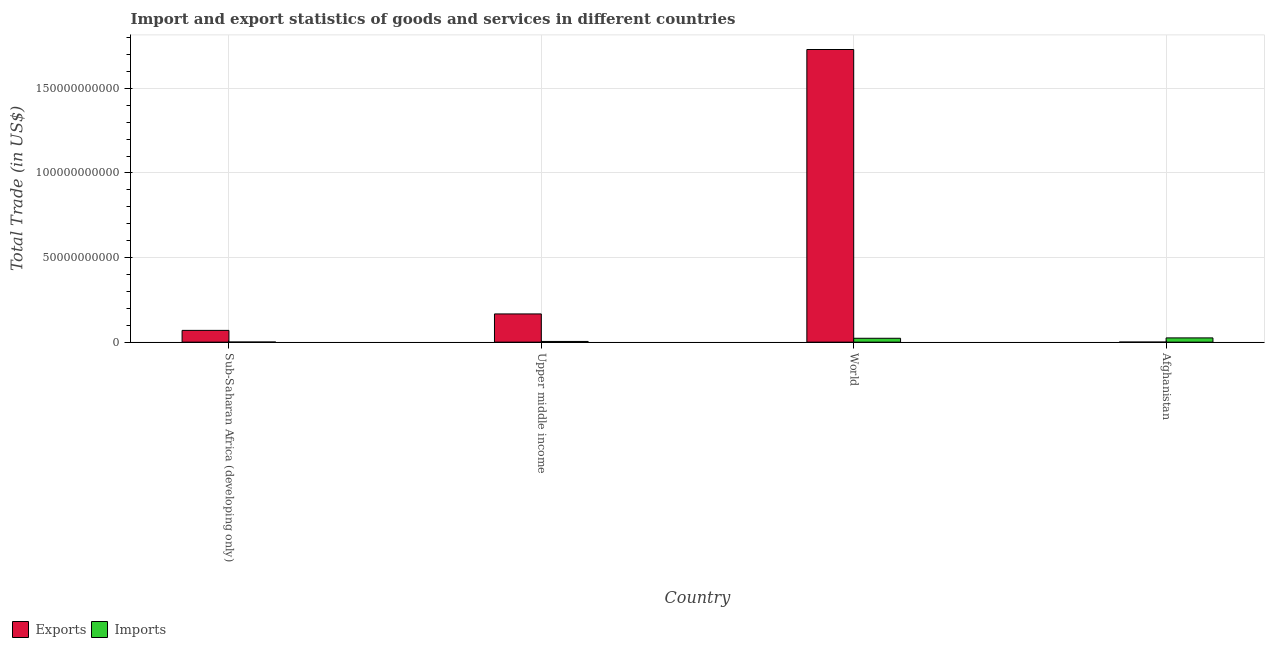How many different coloured bars are there?
Provide a short and direct response. 2. Are the number of bars on each tick of the X-axis equal?
Your answer should be compact. Yes. How many bars are there on the 1st tick from the right?
Offer a very short reply. 2. What is the label of the 2nd group of bars from the left?
Your response must be concise. Upper middle income. In how many cases, is the number of bars for a given country not equal to the number of legend labels?
Provide a succinct answer. 0. What is the imports of goods and services in Afghanistan?
Offer a very short reply. 2.51e+09. Across all countries, what is the maximum imports of goods and services?
Provide a short and direct response. 2.51e+09. Across all countries, what is the minimum imports of goods and services?
Provide a succinct answer. 5.11e+07. In which country was the imports of goods and services maximum?
Offer a terse response. Afghanistan. In which country was the imports of goods and services minimum?
Keep it short and to the point. Sub-Saharan Africa (developing only). What is the total imports of goods and services in the graph?
Offer a terse response. 5.27e+09. What is the difference between the export of goods and services in Afghanistan and that in Sub-Saharan Africa (developing only)?
Provide a short and direct response. -6.93e+09. What is the difference between the export of goods and services in Sub-Saharan Africa (developing only) and the imports of goods and services in World?
Keep it short and to the point. 4.66e+09. What is the average imports of goods and services per country?
Give a very brief answer. 1.32e+09. What is the difference between the imports of goods and services and export of goods and services in Upper middle income?
Your response must be concise. -1.63e+1. In how many countries, is the imports of goods and services greater than 120000000000 US$?
Your answer should be very brief. 0. What is the ratio of the export of goods and services in Sub-Saharan Africa (developing only) to that in World?
Offer a very short reply. 0.04. What is the difference between the highest and the second highest export of goods and services?
Your response must be concise. 1.56e+11. What is the difference between the highest and the lowest imports of goods and services?
Give a very brief answer. 2.46e+09. In how many countries, is the imports of goods and services greater than the average imports of goods and services taken over all countries?
Your answer should be compact. 2. Is the sum of the imports of goods and services in Afghanistan and Sub-Saharan Africa (developing only) greater than the maximum export of goods and services across all countries?
Offer a terse response. No. What does the 2nd bar from the left in World represents?
Keep it short and to the point. Imports. What does the 1st bar from the right in Upper middle income represents?
Provide a short and direct response. Imports. Are all the bars in the graph horizontal?
Make the answer very short. No. Are the values on the major ticks of Y-axis written in scientific E-notation?
Your answer should be very brief. No. Does the graph contain any zero values?
Your answer should be very brief. No. Where does the legend appear in the graph?
Your response must be concise. Bottom left. How are the legend labels stacked?
Keep it short and to the point. Horizontal. What is the title of the graph?
Give a very brief answer. Import and export statistics of goods and services in different countries. What is the label or title of the Y-axis?
Offer a terse response. Total Trade (in US$). What is the Total Trade (in US$) of Exports in Sub-Saharan Africa (developing only)?
Give a very brief answer. 6.95e+09. What is the Total Trade (in US$) in Imports in Sub-Saharan Africa (developing only)?
Offer a very short reply. 5.11e+07. What is the Total Trade (in US$) in Exports in Upper middle income?
Your response must be concise. 1.67e+1. What is the Total Trade (in US$) of Imports in Upper middle income?
Your answer should be very brief. 4.17e+08. What is the Total Trade (in US$) in Exports in World?
Offer a very short reply. 1.73e+11. What is the Total Trade (in US$) in Imports in World?
Your answer should be compact. 2.29e+09. What is the Total Trade (in US$) in Exports in Afghanistan?
Your answer should be very brief. 2.67e+07. What is the Total Trade (in US$) of Imports in Afghanistan?
Offer a very short reply. 2.51e+09. Across all countries, what is the maximum Total Trade (in US$) of Exports?
Provide a short and direct response. 1.73e+11. Across all countries, what is the maximum Total Trade (in US$) in Imports?
Offer a terse response. 2.51e+09. Across all countries, what is the minimum Total Trade (in US$) of Exports?
Offer a very short reply. 2.67e+07. Across all countries, what is the minimum Total Trade (in US$) in Imports?
Keep it short and to the point. 5.11e+07. What is the total Total Trade (in US$) of Exports in the graph?
Provide a short and direct response. 1.97e+11. What is the total Total Trade (in US$) in Imports in the graph?
Your answer should be compact. 5.27e+09. What is the difference between the Total Trade (in US$) of Exports in Sub-Saharan Africa (developing only) and that in Upper middle income?
Offer a terse response. -9.72e+09. What is the difference between the Total Trade (in US$) of Imports in Sub-Saharan Africa (developing only) and that in Upper middle income?
Offer a terse response. -3.66e+08. What is the difference between the Total Trade (in US$) of Exports in Sub-Saharan Africa (developing only) and that in World?
Your response must be concise. -1.66e+11. What is the difference between the Total Trade (in US$) in Imports in Sub-Saharan Africa (developing only) and that in World?
Your answer should be very brief. -2.24e+09. What is the difference between the Total Trade (in US$) in Exports in Sub-Saharan Africa (developing only) and that in Afghanistan?
Give a very brief answer. 6.93e+09. What is the difference between the Total Trade (in US$) in Imports in Sub-Saharan Africa (developing only) and that in Afghanistan?
Keep it short and to the point. -2.46e+09. What is the difference between the Total Trade (in US$) of Exports in Upper middle income and that in World?
Give a very brief answer. -1.56e+11. What is the difference between the Total Trade (in US$) of Imports in Upper middle income and that in World?
Make the answer very short. -1.88e+09. What is the difference between the Total Trade (in US$) in Exports in Upper middle income and that in Afghanistan?
Make the answer very short. 1.66e+1. What is the difference between the Total Trade (in US$) of Imports in Upper middle income and that in Afghanistan?
Give a very brief answer. -2.10e+09. What is the difference between the Total Trade (in US$) of Exports in World and that in Afghanistan?
Keep it short and to the point. 1.73e+11. What is the difference between the Total Trade (in US$) of Imports in World and that in Afghanistan?
Your answer should be very brief. -2.18e+08. What is the difference between the Total Trade (in US$) of Exports in Sub-Saharan Africa (developing only) and the Total Trade (in US$) of Imports in Upper middle income?
Ensure brevity in your answer.  6.54e+09. What is the difference between the Total Trade (in US$) in Exports in Sub-Saharan Africa (developing only) and the Total Trade (in US$) in Imports in World?
Keep it short and to the point. 4.66e+09. What is the difference between the Total Trade (in US$) in Exports in Sub-Saharan Africa (developing only) and the Total Trade (in US$) in Imports in Afghanistan?
Ensure brevity in your answer.  4.44e+09. What is the difference between the Total Trade (in US$) in Exports in Upper middle income and the Total Trade (in US$) in Imports in World?
Provide a short and direct response. 1.44e+1. What is the difference between the Total Trade (in US$) of Exports in Upper middle income and the Total Trade (in US$) of Imports in Afghanistan?
Offer a terse response. 1.42e+1. What is the difference between the Total Trade (in US$) in Exports in World and the Total Trade (in US$) in Imports in Afghanistan?
Your response must be concise. 1.70e+11. What is the average Total Trade (in US$) in Exports per country?
Provide a succinct answer. 4.92e+1. What is the average Total Trade (in US$) in Imports per country?
Make the answer very short. 1.32e+09. What is the difference between the Total Trade (in US$) of Exports and Total Trade (in US$) of Imports in Sub-Saharan Africa (developing only)?
Offer a terse response. 6.90e+09. What is the difference between the Total Trade (in US$) in Exports and Total Trade (in US$) in Imports in Upper middle income?
Provide a succinct answer. 1.63e+1. What is the difference between the Total Trade (in US$) of Exports and Total Trade (in US$) of Imports in World?
Provide a succinct answer. 1.71e+11. What is the difference between the Total Trade (in US$) of Exports and Total Trade (in US$) of Imports in Afghanistan?
Provide a succinct answer. -2.49e+09. What is the ratio of the Total Trade (in US$) of Exports in Sub-Saharan Africa (developing only) to that in Upper middle income?
Offer a terse response. 0.42. What is the ratio of the Total Trade (in US$) in Imports in Sub-Saharan Africa (developing only) to that in Upper middle income?
Your answer should be very brief. 0.12. What is the ratio of the Total Trade (in US$) of Exports in Sub-Saharan Africa (developing only) to that in World?
Offer a terse response. 0.04. What is the ratio of the Total Trade (in US$) in Imports in Sub-Saharan Africa (developing only) to that in World?
Offer a very short reply. 0.02. What is the ratio of the Total Trade (in US$) in Exports in Sub-Saharan Africa (developing only) to that in Afghanistan?
Provide a short and direct response. 260.78. What is the ratio of the Total Trade (in US$) of Imports in Sub-Saharan Africa (developing only) to that in Afghanistan?
Provide a succinct answer. 0.02. What is the ratio of the Total Trade (in US$) of Exports in Upper middle income to that in World?
Offer a terse response. 0.1. What is the ratio of the Total Trade (in US$) of Imports in Upper middle income to that in World?
Your answer should be compact. 0.18. What is the ratio of the Total Trade (in US$) of Exports in Upper middle income to that in Afghanistan?
Your answer should be compact. 625.33. What is the ratio of the Total Trade (in US$) in Imports in Upper middle income to that in Afghanistan?
Give a very brief answer. 0.17. What is the ratio of the Total Trade (in US$) of Exports in World to that in Afghanistan?
Offer a very short reply. 6486.07. What is the ratio of the Total Trade (in US$) in Imports in World to that in Afghanistan?
Give a very brief answer. 0.91. What is the difference between the highest and the second highest Total Trade (in US$) in Exports?
Your response must be concise. 1.56e+11. What is the difference between the highest and the second highest Total Trade (in US$) of Imports?
Give a very brief answer. 2.18e+08. What is the difference between the highest and the lowest Total Trade (in US$) of Exports?
Offer a terse response. 1.73e+11. What is the difference between the highest and the lowest Total Trade (in US$) in Imports?
Provide a short and direct response. 2.46e+09. 